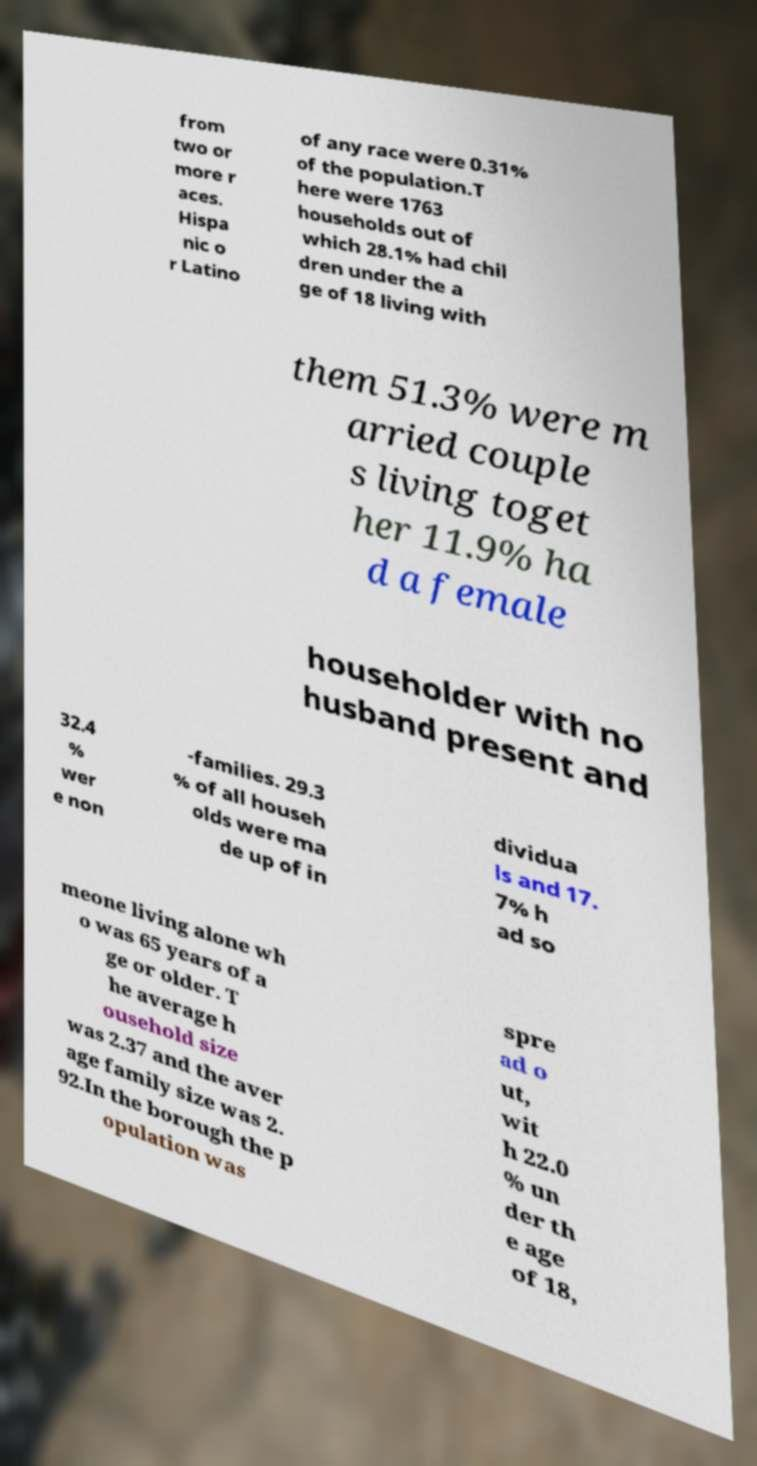Please read and relay the text visible in this image. What does it say? from two or more r aces. Hispa nic o r Latino of any race were 0.31% of the population.T here were 1763 households out of which 28.1% had chil dren under the a ge of 18 living with them 51.3% were m arried couple s living toget her 11.9% ha d a female householder with no husband present and 32.4 % wer e non -families. 29.3 % of all househ olds were ma de up of in dividua ls and 17. 7% h ad so meone living alone wh o was 65 years of a ge or older. T he average h ousehold size was 2.37 and the aver age family size was 2. 92.In the borough the p opulation was spre ad o ut, wit h 22.0 % un der th e age of 18, 